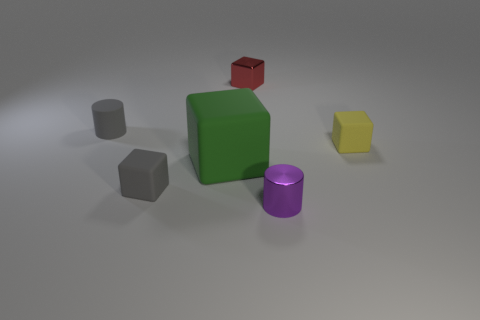Add 1 purple shiny things. How many objects exist? 7 Subtract all tiny gray cubes. How many cubes are left? 3 Subtract all cylinders. How many objects are left? 4 Subtract 4 blocks. How many blocks are left? 0 Subtract all blue blocks. Subtract all cyan cylinders. How many blocks are left? 4 Subtract all blue blocks. How many gray cylinders are left? 1 Subtract all small red metallic objects. Subtract all tiny gray rubber things. How many objects are left? 3 Add 5 gray things. How many gray things are left? 7 Add 5 tiny green shiny cylinders. How many tiny green shiny cylinders exist? 5 Subtract all purple cylinders. How many cylinders are left? 1 